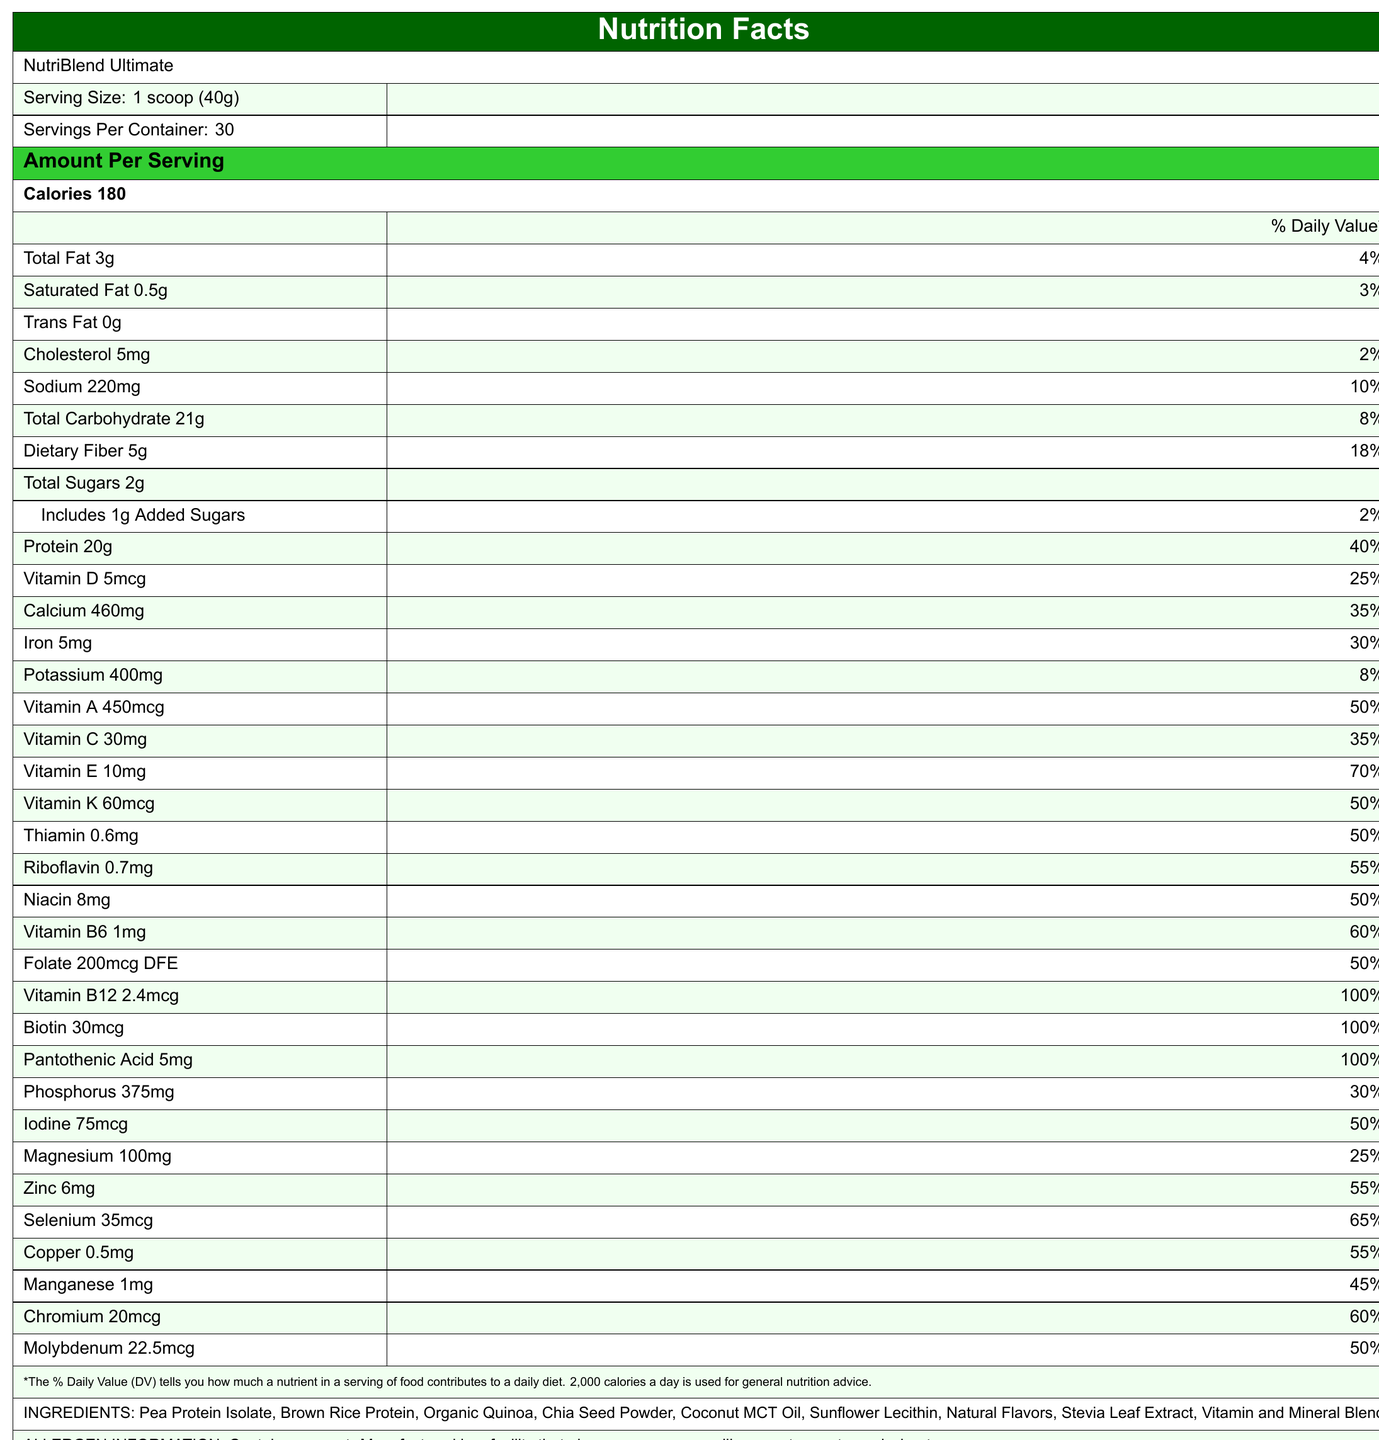what is the serving size? The document states that the serving size is 1 scoop (40g).
Answer: 1 scoop (40g) What is the calorie count per serving? The document lists 180 calories per serving under the Amount Per Serving header.
Answer: 180 calories What are the first three ingredients listed? The document lists the ingredients in a specified order, with Pea Protein Isolate, Brown Rice Protein, and Organic Quinoa as the first three.
Answer: Pea Protein Isolate, Brown Rice Protein, Organic Quinoa How much sodium does one serving contain and what is its daily value percentage? According to the document, one serving contains 220mg of sodium, which is 10% of the daily value.
Answer: 220mg, 10% What is the total carbohydrate amount per serving? The document states that the total carbohydrate amount per serving is 21g.
Answer: 21g Does the product contain any trans fat? The product has 0g of trans fat as listed in the document.
Answer: No How many servings are there per container? A. 15 B. 20 C. 30 D. 40 The document indicates that there are 30 servings per container.
Answer: C. 30 What is the protein content of the shake, and what percentage of the daily value does it fulfill? A. 15g, 30% B. 20g, 40% C. 22g, 45% D. 25g, 50% According to the document, the shake contains 20g of protein per serving, which is 40% of the daily value.
Answer: B. 20g, 40% Is the product manufactured in a facility that processes soy? The allergen information section mentions that the product is manufactured in a facility that also processes soy.
Answer: Yes Does the product contribute to iron intake, and if so, by what percentage? The document lists that the product provides 5mg of iron, which is 30% of the daily value.
Answer: Yes, 30% Summarize the key nutritional features and extras provided in the document. The summary encapsulates the main components from the nutrition facts, ingredient sourcing, and additional statistical information provided in the document.
Answer: The document outlines the nutrition facts for NutriBlend Ultimate, a meal replacement shake. One serving size is 40g, with 180 calories per serving, and includes macronutrients like 3g of fat, 21g of carbohydrates, and 20g of protein. It is rich in vitamins and minerals such as Vitamin A (50% DV), Vitamin C (35% DV), Vitamin D (25% DV), and Iron (30% DV). Key ingredients include Pea Protein Isolate, Brown Rice Protein, Organic Quinoa, among others. It's noted to have allergen information and ingredient sourcing details, with additional brand loyalty statistics and product success metrics. What is the average customer lifetime value? The document specifies the average customer lifetime value as $450 under brand loyalty statistics.
Answer: $450 What are the sourcing details of the pea protein? The ingredient sourcing section details that the pea protein is sustainably sourced from Canadian yellow peas.
Answer: Sustainably sourced from Canadian yellow peas Can we determine the specific amino acid profile of the protein blend from the document? The document does not provide details on the specific amino acid profile of the protein blend.
Answer: Cannot be determined What is the net promoter score of the product? A. 65 B. 72 C. 78 D. 82 The net promoter score listed in the document is 72.
Answer: B. 72 Explain the amount and daily value percentage of Vitamin E in the product. The document lists that each serving contains 10mg of Vitamin E, fulfilling 70% of the daily value.
Answer: 10mg, 70% 